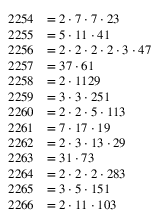<formula> <loc_0><loc_0><loc_500><loc_500>\begin{array} { r l } { 2 2 5 4 } & { = 2 \cdot 7 \cdot 7 \cdot 2 3 } \\ { 2 2 5 5 } & { = 5 \cdot 1 1 \cdot 4 1 } \\ { 2 2 5 6 } & { = 2 \cdot 2 \cdot 2 \cdot 2 \cdot 3 \cdot 4 7 } \\ { 2 2 5 7 } & { = 3 7 \cdot 6 1 } \\ { 2 2 5 8 } & { = 2 \cdot 1 1 2 9 } \\ { 2 2 5 9 } & { = 3 \cdot 3 \cdot 2 5 1 } \\ { 2 2 6 0 } & { = 2 \cdot 2 \cdot 5 \cdot 1 1 3 } \\ { 2 2 6 1 } & { = 7 \cdot 1 7 \cdot 1 9 } \\ { 2 2 6 2 } & { = 2 \cdot 3 \cdot 1 3 \cdot 2 9 } \\ { 2 2 6 3 } & { = 3 1 \cdot 7 3 } \\ { 2 2 6 4 } & { = 2 \cdot 2 \cdot 2 \cdot 2 8 3 } \\ { 2 2 6 5 } & { = 3 \cdot 5 \cdot 1 5 1 } \\ { 2 2 6 6 } & { = 2 \cdot 1 1 \cdot 1 0 3 } \end{array}</formula> 